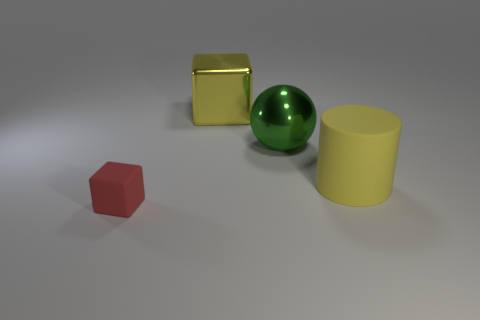Add 3 large red rubber balls. How many objects exist? 7 Subtract all cylinders. How many objects are left? 3 Add 1 large green things. How many large green things are left? 2 Add 1 tiny matte cubes. How many tiny matte cubes exist? 2 Subtract 1 green balls. How many objects are left? 3 Subtract all green metallic balls. Subtract all metal balls. How many objects are left? 2 